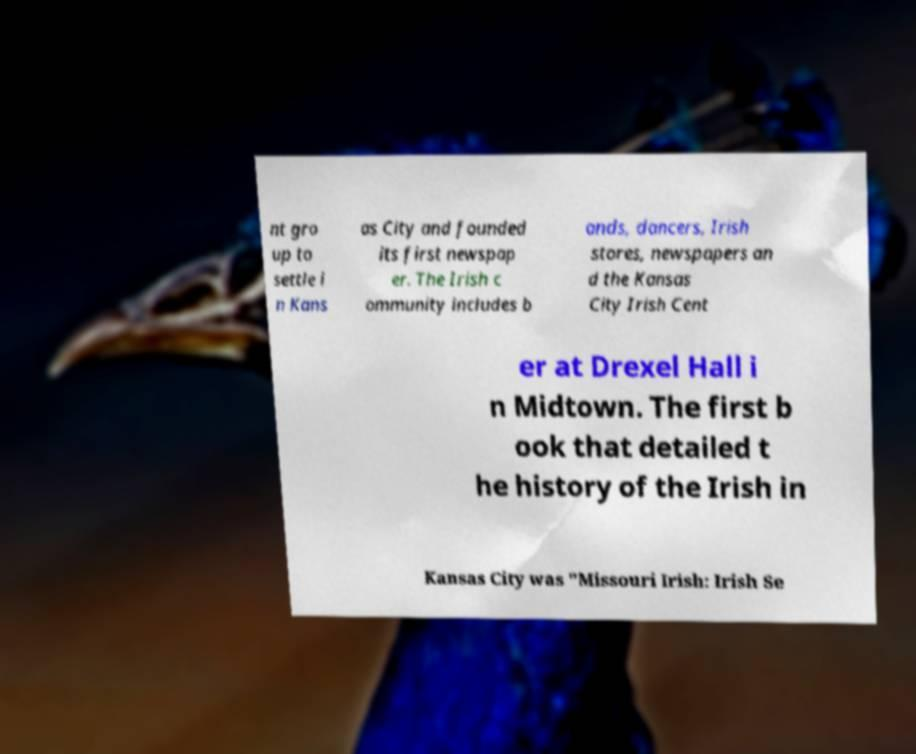Can you accurately transcribe the text from the provided image for me? nt gro up to settle i n Kans as City and founded its first newspap er. The Irish c ommunity includes b ands, dancers, Irish stores, newspapers an d the Kansas City Irish Cent er at Drexel Hall i n Midtown. The first b ook that detailed t he history of the Irish in Kansas City was "Missouri Irish: Irish Se 